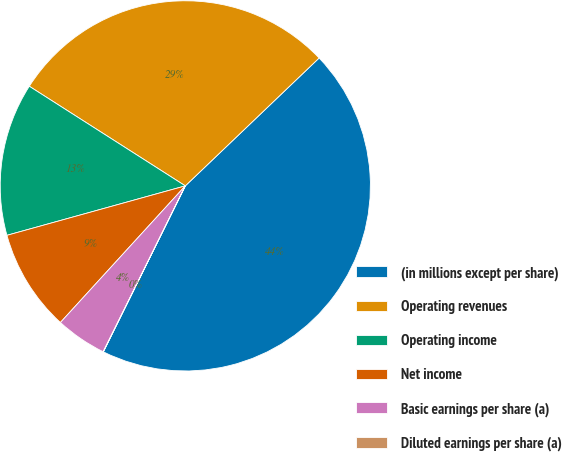Convert chart. <chart><loc_0><loc_0><loc_500><loc_500><pie_chart><fcel>(in millions except per share)<fcel>Operating revenues<fcel>Operating income<fcel>Net income<fcel>Basic earnings per share (a)<fcel>Diluted earnings per share (a)<nl><fcel>44.44%<fcel>28.82%<fcel>13.35%<fcel>8.91%<fcel>4.47%<fcel>0.02%<nl></chart> 